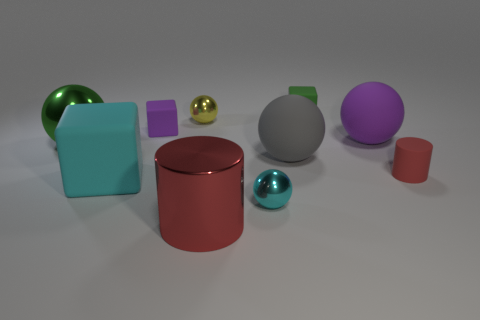Are there any large shiny objects on the right side of the big matte block?
Your answer should be compact. Yes. What is the material of the thing that is the same color as the large cylinder?
Your answer should be compact. Rubber. Does the small block that is in front of the tiny yellow object have the same material as the yellow sphere?
Your answer should be compact. No. There is a tiny ball that is behind the metal thing that is left of the purple rubber block; is there a cyan thing that is on the left side of it?
Your answer should be very brief. Yes. How many cylinders are red things or big red metal objects?
Give a very brief answer. 2. What is the small green cube right of the cyan block made of?
Make the answer very short. Rubber. There is a thing that is the same color as the big cylinder; what size is it?
Your response must be concise. Small. Does the tiny metallic sphere in front of the tiny purple matte object have the same color as the matte cube in front of the green metallic thing?
Make the answer very short. Yes. How many objects are purple cubes or tiny objects?
Your response must be concise. 5. What number of other objects are there of the same shape as the large purple matte thing?
Your answer should be compact. 4. 